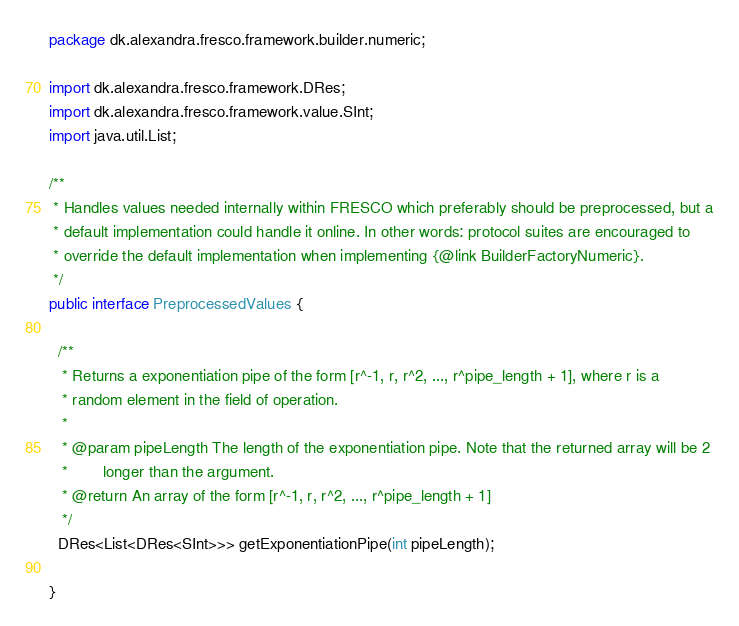<code> <loc_0><loc_0><loc_500><loc_500><_Java_>package dk.alexandra.fresco.framework.builder.numeric;

import dk.alexandra.fresco.framework.DRes;
import dk.alexandra.fresco.framework.value.SInt;
import java.util.List;

/**
 * Handles values needed internally within FRESCO which preferably should be preprocessed, but a
 * default implementation could handle it online. In other words: protocol suites are encouraged to
 * override the default implementation when implementing {@link BuilderFactoryNumeric}.
 */
public interface PreprocessedValues {

  /**
   * Returns a exponentiation pipe of the form [r^-1, r, r^2, ..., r^pipe_length + 1], where r is a
   * random element in the field of operation.
   *
   * @param pipeLength The length of the exponentiation pipe. Note that the returned array will be 2
   *        longer than the argument.
   * @return An array of the form [r^-1, r, r^2, ..., r^pipe_length + 1]
   */
  DRes<List<DRes<SInt>>> getExponentiationPipe(int pipeLength);

}
</code> 